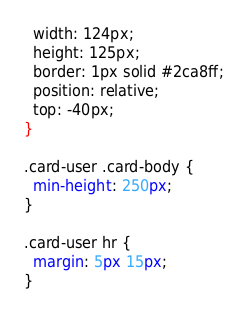Convert code to text. <code><loc_0><loc_0><loc_500><loc_500><_CSS_>  width: 124px;
  height: 125px;
  border: 1px solid #2ca8ff;
  position: relative;
  top: -40px;
}

.card-user .card-body {
  min-height: 250px;
}

.card-user hr {
  margin: 5px 15px;
}
</code> 